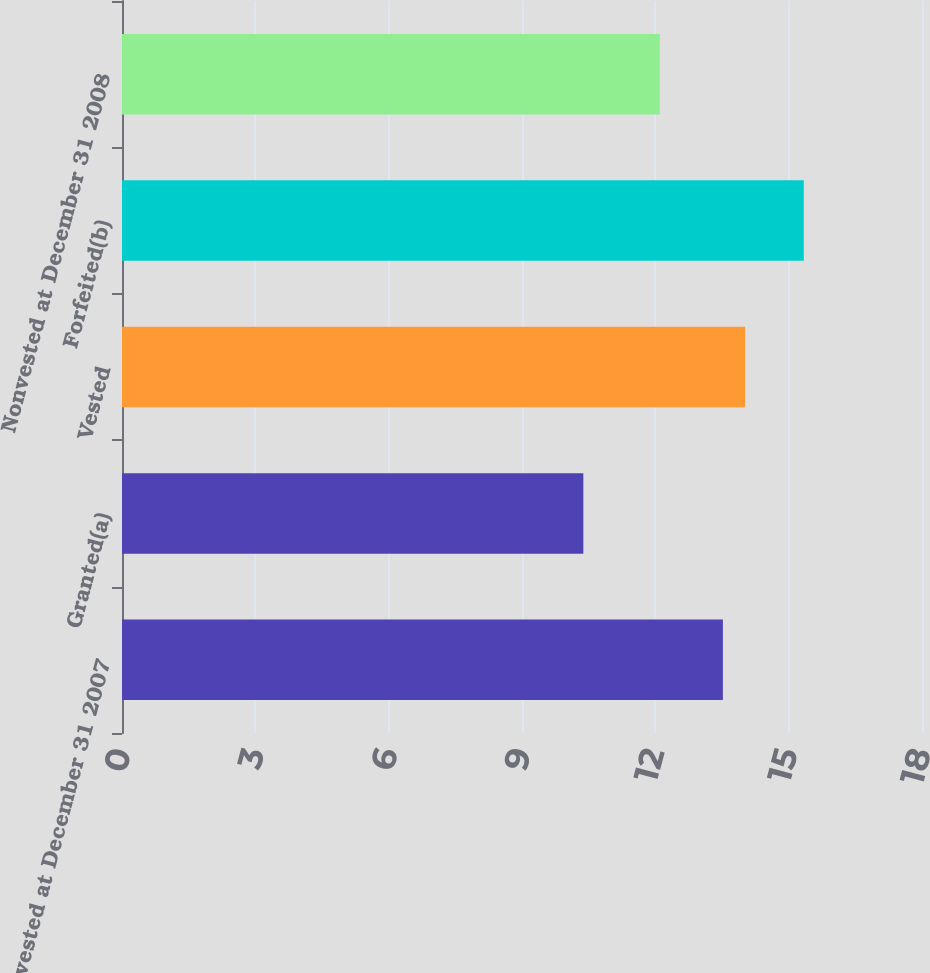<chart> <loc_0><loc_0><loc_500><loc_500><bar_chart><fcel>Nonvested at December 31 2007<fcel>Granted(a)<fcel>Vested<fcel>Forfeited(b)<fcel>Nonvested at December 31 2008<nl><fcel>13.52<fcel>10.38<fcel>14.02<fcel>15.34<fcel>12.1<nl></chart> 